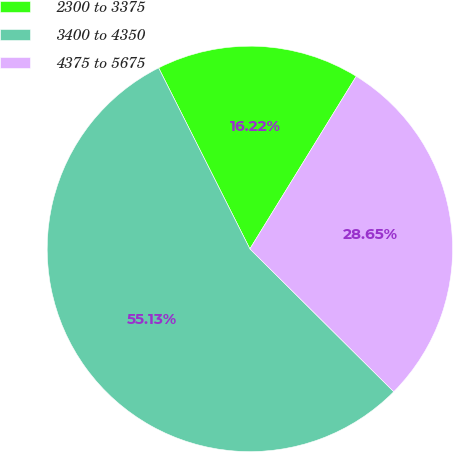Convert chart. <chart><loc_0><loc_0><loc_500><loc_500><pie_chart><fcel>2300 to 3375<fcel>3400 to 4350<fcel>4375 to 5675<nl><fcel>16.22%<fcel>55.12%<fcel>28.65%<nl></chart> 